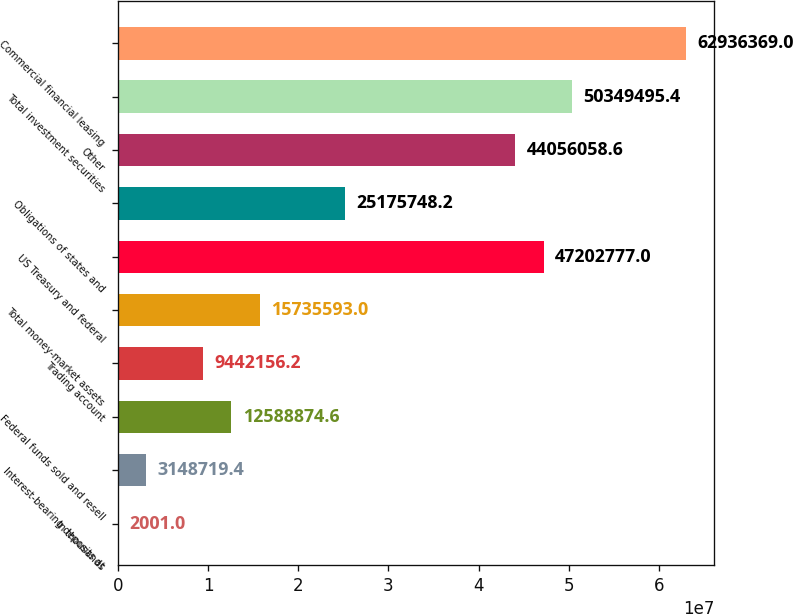Convert chart. <chart><loc_0><loc_0><loc_500><loc_500><bar_chart><fcel>In thousands<fcel>Interest-bearing deposits at<fcel>Federal funds sold and resell<fcel>Trading account<fcel>Total money-market assets<fcel>US Treasury and federal<fcel>Obligations of states and<fcel>Other<fcel>Total investment securities<fcel>Commercial financial leasing<nl><fcel>2001<fcel>3.14872e+06<fcel>1.25889e+07<fcel>9.44216e+06<fcel>1.57356e+07<fcel>4.72028e+07<fcel>2.51757e+07<fcel>4.40561e+07<fcel>5.03495e+07<fcel>6.29364e+07<nl></chart> 